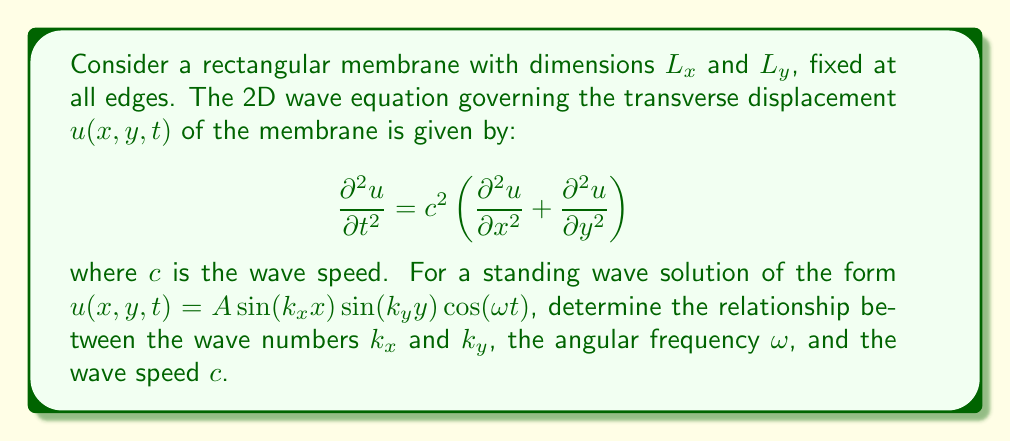What is the answer to this math problem? To solve this problem, we'll follow these steps:

1) First, let's substitute the proposed standing wave solution into the 2D wave equation:

   $u(x,y,t) = A \sin(k_x x) \sin(k_y y) \cos(\omega t)$

2) Calculate the necessary partial derivatives:

   $\frac{\partial^2 u}{\partial t^2} = -A \omega^2 \sin(k_x x) \sin(k_y y) \cos(\omega t)$
   
   $\frac{\partial^2 u}{\partial x^2} = -A k_x^2 \sin(k_x x) \sin(k_y y) \cos(\omega t)$
   
   $\frac{\partial^2 u}{\partial y^2} = -A k_y^2 \sin(k_x x) \sin(k_y y) \cos(\omega t)$

3) Substitute these derivatives into the 2D wave equation:

   $-A \omega^2 \sin(k_x x) \sin(k_y y) \cos(\omega t) = c^2 [-A k_x^2 \sin(k_x x) \sin(k_y y) \cos(\omega t) - A k_y^2 \sin(k_x x) \sin(k_y y) \cos(\omega t)]$

4) Cancel out common terms on both sides:

   $\omega^2 = c^2 (k_x^2 + k_y^2)$

5) This equation relates the angular frequency $\omega$ to the wave numbers $k_x$ and $k_y$, and the wave speed $c$. It's known as the dispersion relation for the 2D wave equation.

6) We can also express this in terms of the wavelengths $\lambda_x$ and $\lambda_y$, using the relations $k_x = \frac{2\pi}{\lambda_x}$ and $k_y = \frac{2\pi}{\lambda_y}$:

   $\omega^2 = c^2 \left(\frac{4\pi^2}{\lambda_x^2} + \frac{4\pi^2}{\lambda_y^2}\right)$

This relationship shows how the frequency of the standing wave depends on the wavelengths in both directions and the wave speed in the membrane.
Answer: $\omega^2 = c^2 (k_x^2 + k_y^2)$ 